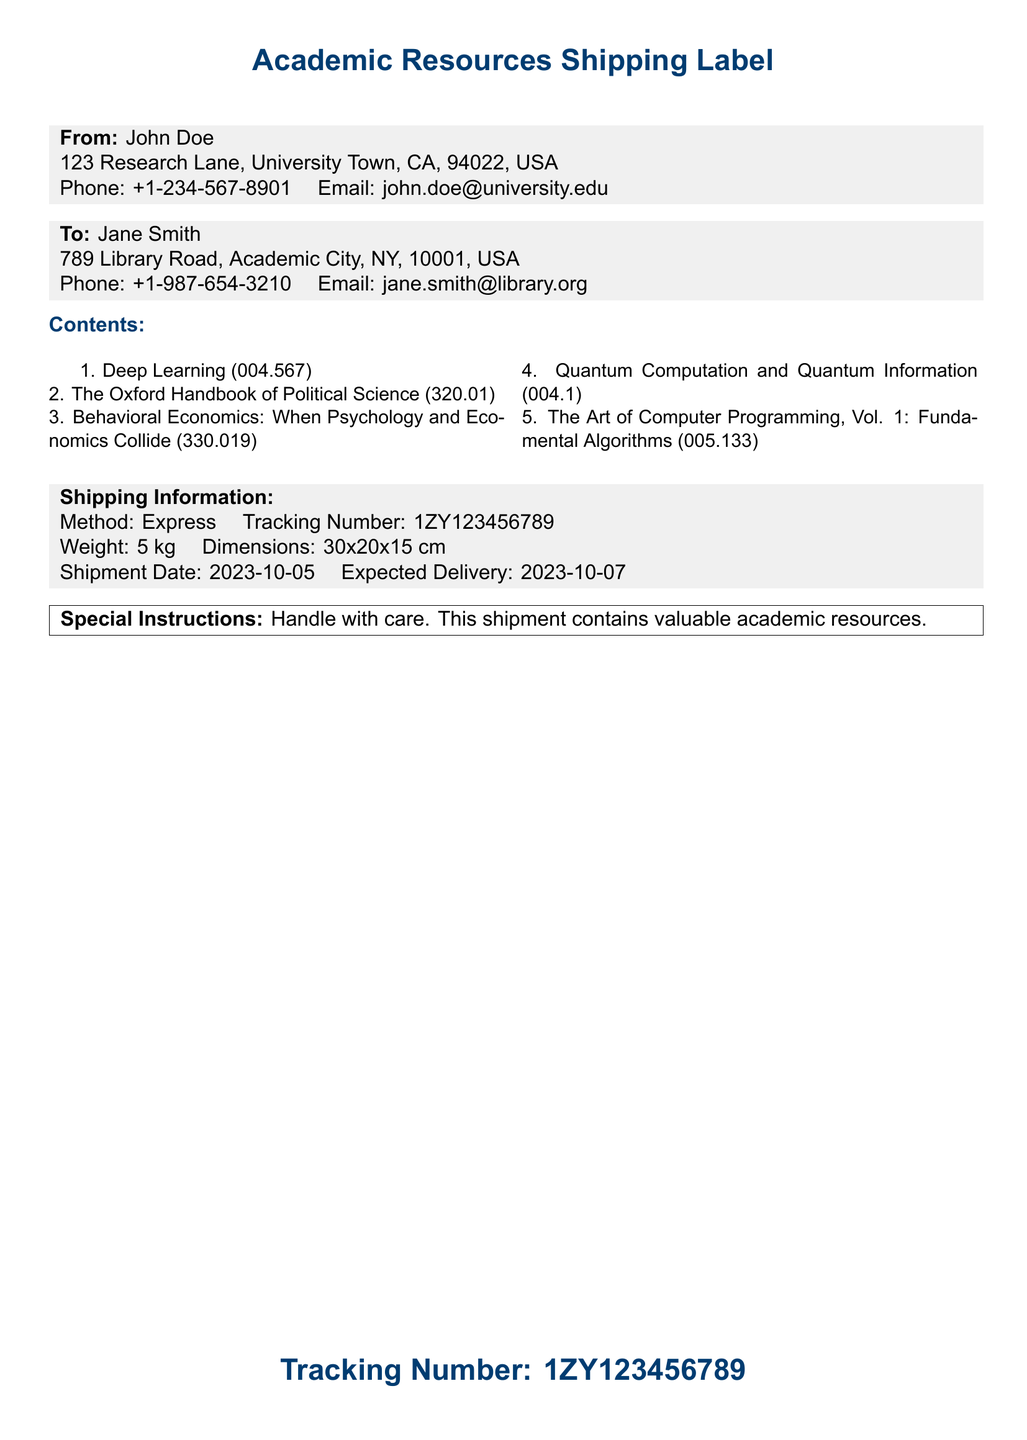what is the title of the first book? The first book listed in the contents section is "Deep Learning."
Answer: Deep Learning who is the sender of this shipment? The sender is John Doe, as mentioned in the 'From' section.
Answer: John Doe what is the tracking number for this shipment? The tracking number is provided at the bottom of the document.
Answer: 1ZY123456789 what is the expected delivery date? The expected delivery date is specified in the shipping information section.
Answer: 2023-10-07 how many books are included in the shipment? The total number of books listed in the contents section is five.
Answer: 5 what is the weight of the shipment? The weight is listed in the shipping information.
Answer: 5 kg what are the dimensions of the shipment? The dimensions are specified in the shipping section of the label.
Answer: 30x20x15 cm who is the recipient of this shipment? The recipient's name is mentioned in the 'To' section.
Answer: Jane Smith what is the shipping method used? The shipping method is noted in the shipping information section.
Answer: Express 